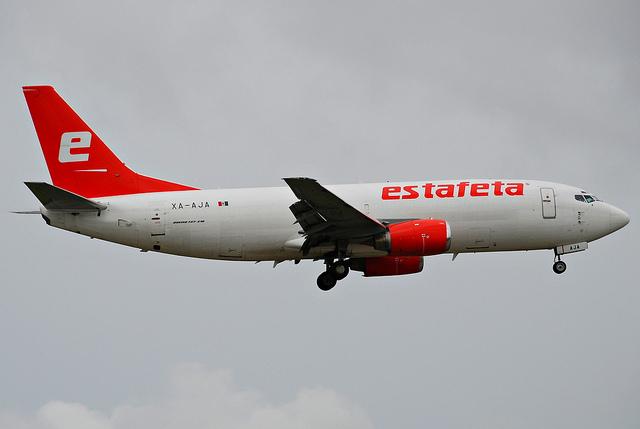What is written on the plane?
Be succinct. Estafeta. What color is the plane's tail?
Answer briefly. Red. Is the e on the tail upper case or lower?
Concise answer only. Lower. 